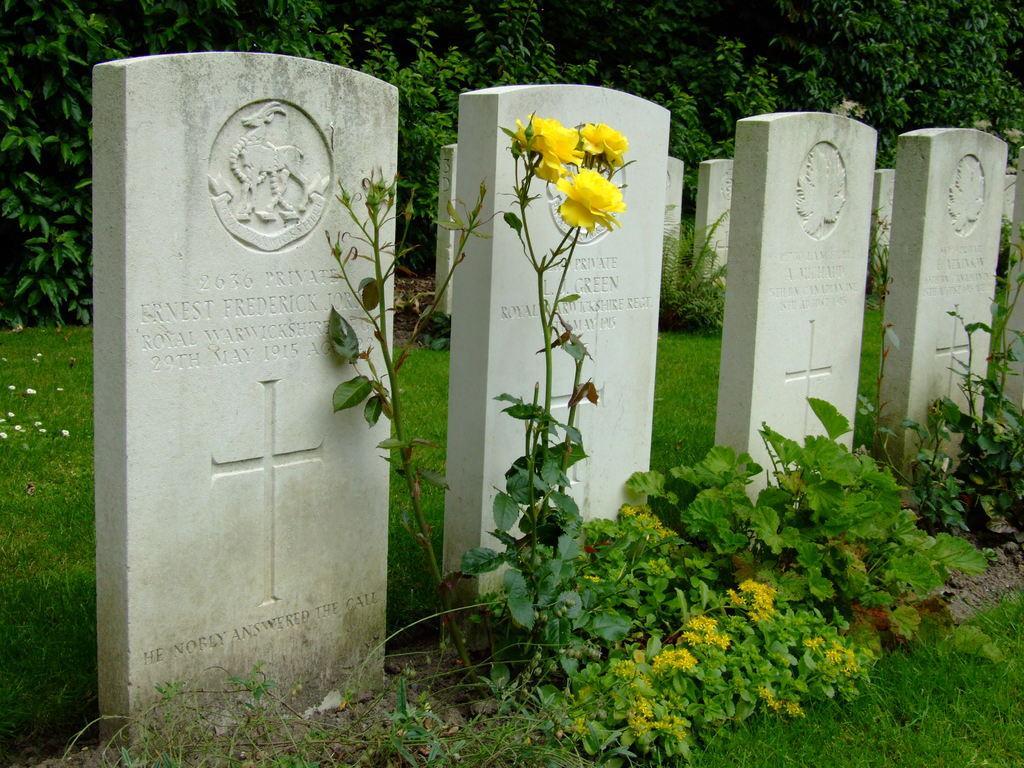Can you describe this image briefly? In this image we can see graves with text and design on that. On the ground there is grass. Also there are plants with flowers. In the background we can see stems with leaves. 